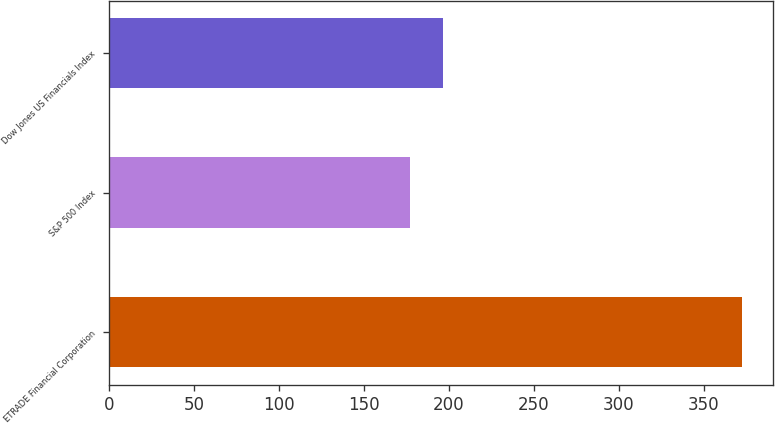Convert chart. <chart><loc_0><loc_0><loc_500><loc_500><bar_chart><fcel>ETRADE Financial Corporation<fcel>S&P 500 Index<fcel>Dow Jones US Financials Index<nl><fcel>372.36<fcel>177.01<fcel>196.54<nl></chart> 